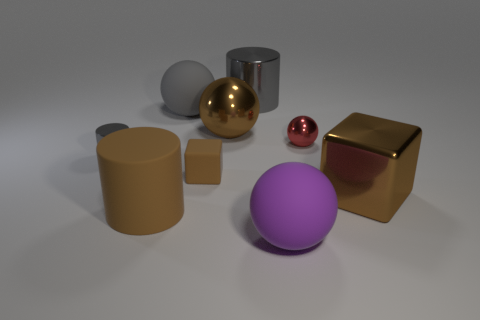There is a small metal object that is the same shape as the large purple thing; what color is it?
Make the answer very short. Red. Is the red thing the same size as the purple ball?
Your answer should be very brief. No. How many other objects are the same size as the gray rubber sphere?
Your answer should be very brief. 5. How many things are cylinders that are in front of the tiny ball or cubes that are right of the tiny red shiny ball?
Your response must be concise. 3. What shape is the gray metal thing that is the same size as the purple object?
Provide a short and direct response. Cylinder. What size is the other ball that is made of the same material as the red sphere?
Make the answer very short. Large. Do the big purple object and the red metal object have the same shape?
Offer a terse response. Yes. There is a shiny cube that is the same size as the purple ball; what color is it?
Provide a short and direct response. Brown. There is another gray metal object that is the same shape as the small gray metallic object; what is its size?
Offer a terse response. Large. What is the shape of the tiny shiny object that is to the left of the small sphere?
Your answer should be compact. Cylinder. 